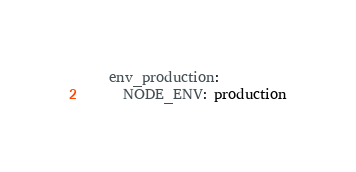Convert code to text. <code><loc_0><loc_0><loc_500><loc_500><_YAML_>    env_production:
      NODE_ENV: production
</code> 